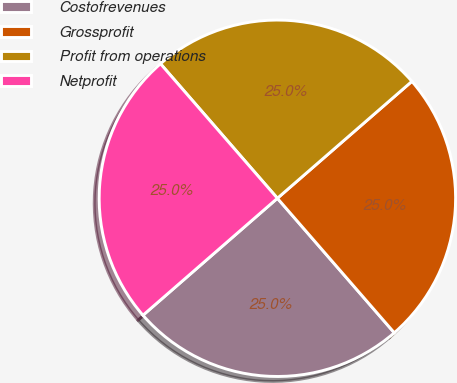<chart> <loc_0><loc_0><loc_500><loc_500><pie_chart><fcel>Costofrevenues<fcel>Grossprofit<fcel>Profit from operations<fcel>Netprofit<nl><fcel>24.99%<fcel>25.0%<fcel>25.0%<fcel>25.01%<nl></chart> 